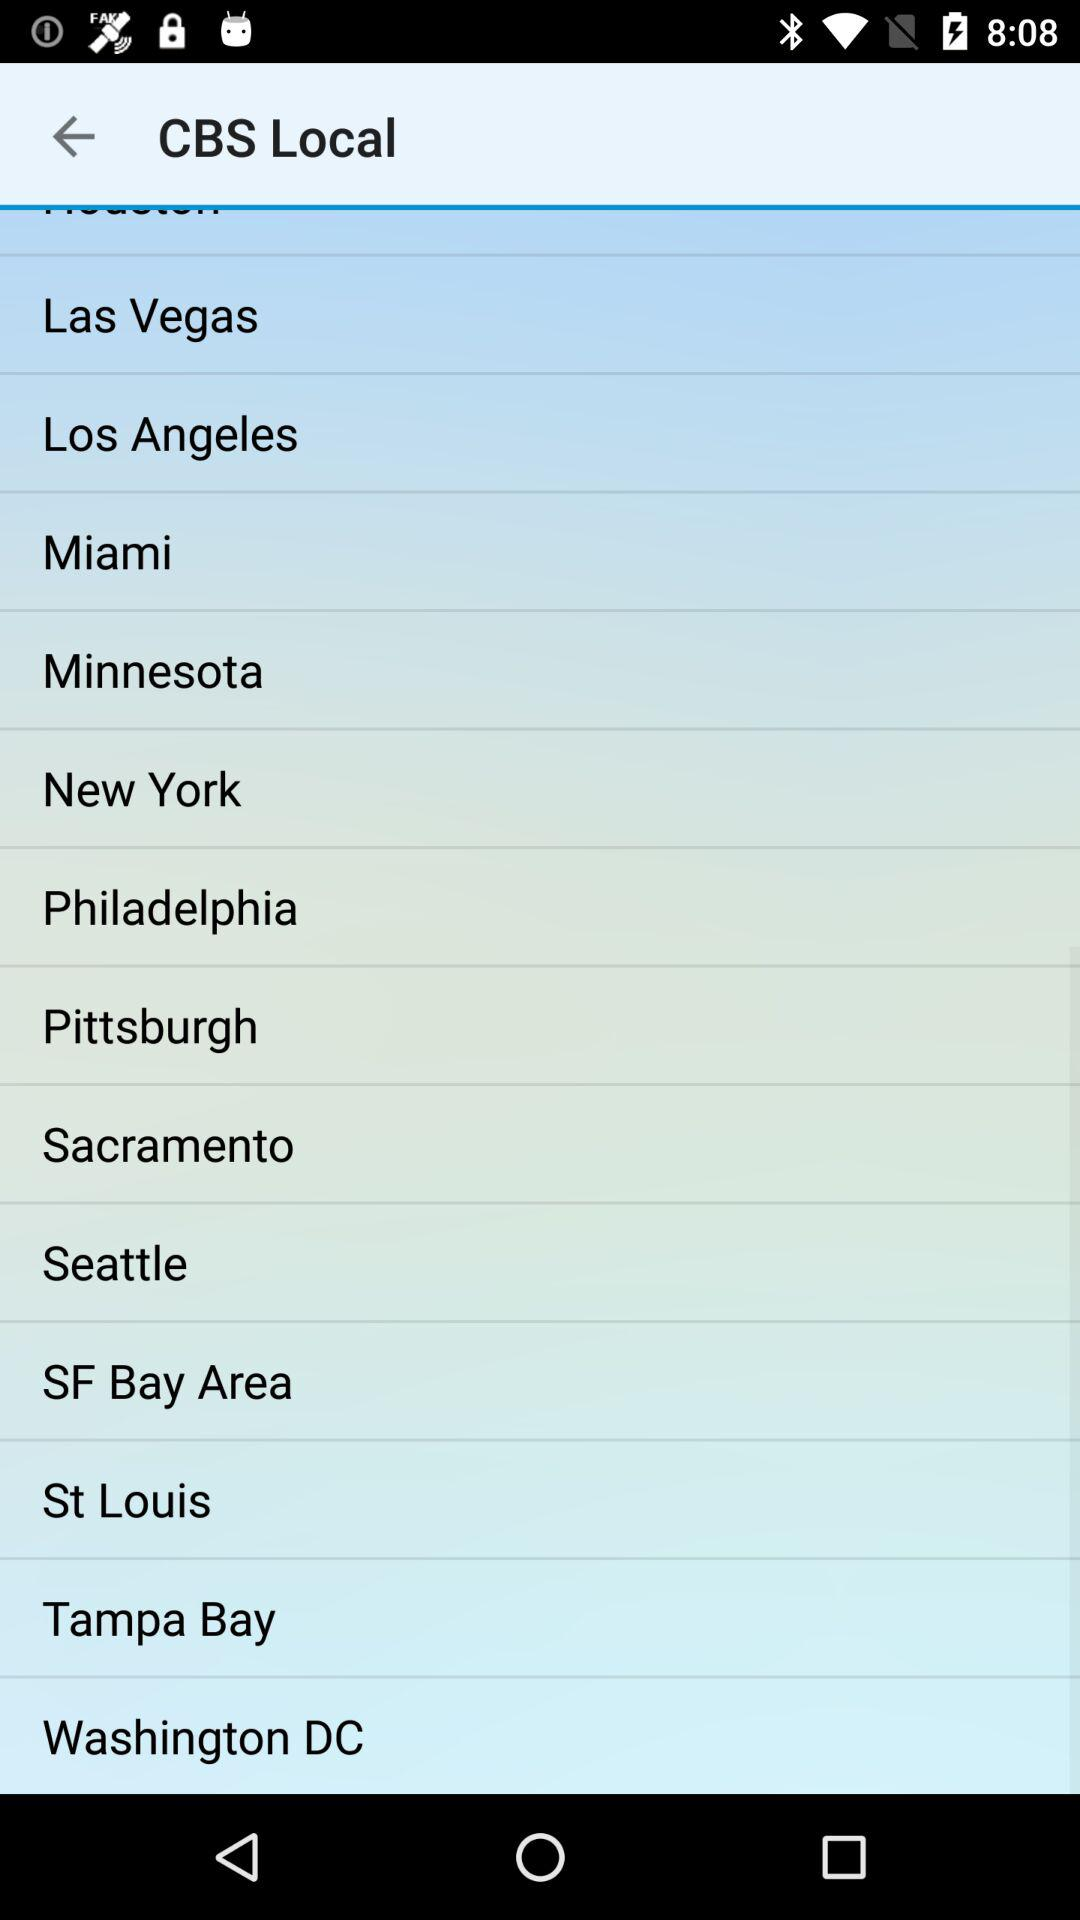What is the application name?
When the provided information is insufficient, respond with <no answer>. <no answer> 